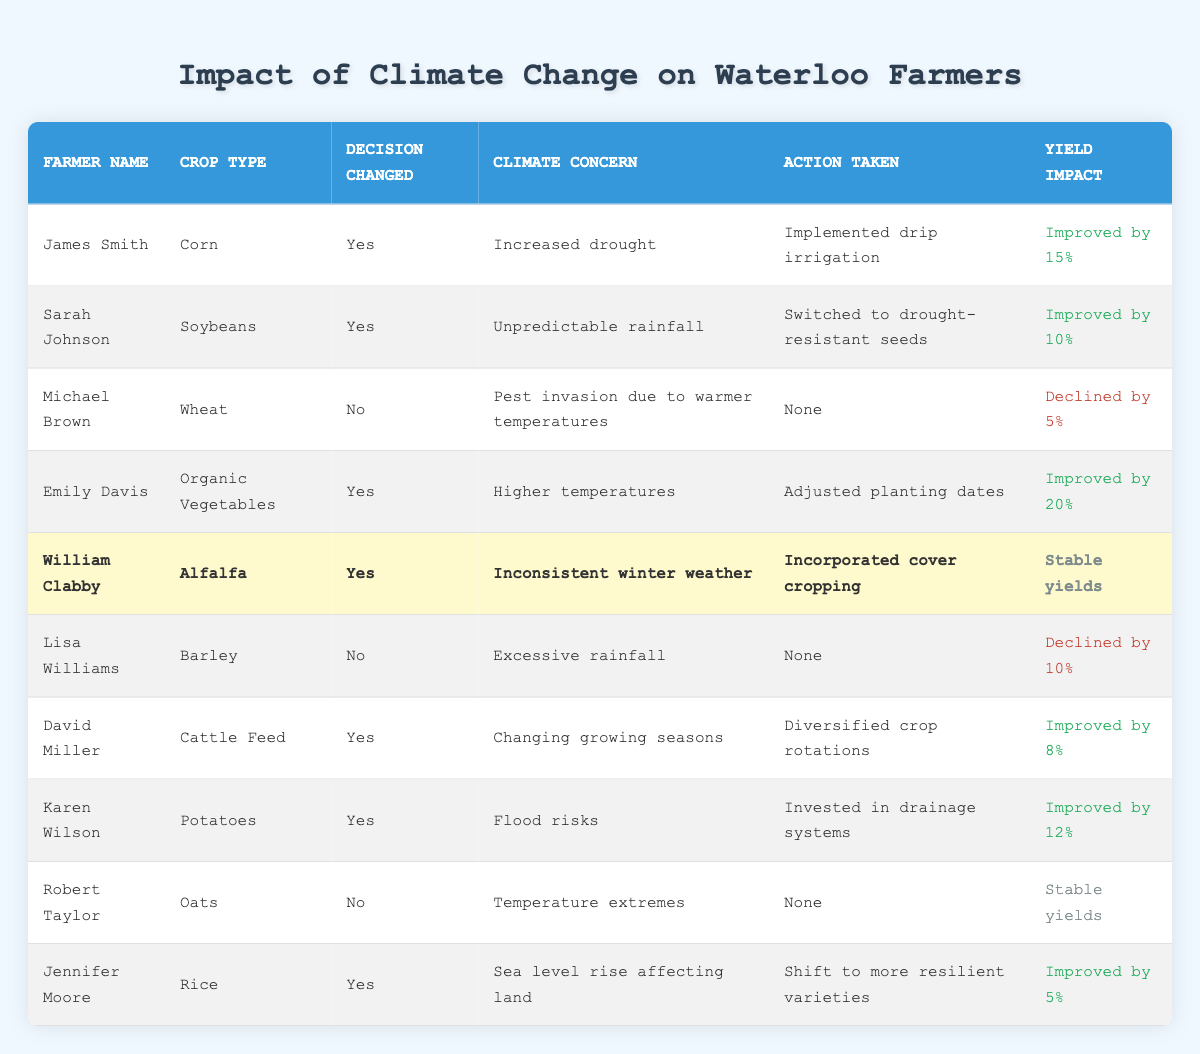What is the action taken by James Smith for the climate concern? In the table, we look for James Smith's row. In that row, the action column states "Implemented drip irrigation," which is his action corresponding to the climate concern of increased drought.
Answer: Implemented drip irrigation How many farmers changed their decisions? To find this, I count the rows where "Decision Changed" is marked as "Yes." There are six farmers with this mark: James Smith, Sarah Johnson, Emily Davis, William Clabby, David Miller, Karen Wilson, and Jennifer Moore.
Answer: 6 What is the yield impact for Michael Brown's wheat? I locate Michael Brown in the table and find the corresponding yield impact in his row. The yield impact column states "Declined by 5%," indicating the effect of his decisions.
Answer: Declined by 5% Which crop type had the highest yield improvement? I examine each yield impact in the table to find maximum improvement. Among the records, Emily Davis with "Organic Vegetables" shows the highest yield improvement of "Improved by 20%."
Answer: Organic Vegetables Did William Clabby change his farming decision? Looking at the "Decision Changed" column for William Clabby, it shows "Yes," confirming that he did change his decision based on his climate concern.
Answer: Yes What is the average percentage yield improvement among farmers who changed their decisions? I sum the yield improvements of those who changed their decisions (15% + 10% + 20% + 8% + 12% + 5% = 80%) and divide by the number of farmers who changed their decisions (6). The average yield improvement calculation is thus 80% / 6 = 13.33%.
Answer: 13.33% Is there any farmer whose action taken is to implement cover cropping? Checking the action taken column, I find that only William Clabby has "Incorporated cover cropping" as an action. Therefore, the answer to this question must be "Yes."
Answer: Yes What are the climate concerns expressed by farmers who did not change their decisions? I list the climate concerns of farmers you didn't change their decisions. Michael Brown mentions "Pest invasion due to warmer temperatures," Lisa Williams mentions "Excessive rainfall," and Robert Taylor mentions "Temperature extremes."
Answer: Pest invasion due to warmer temperatures, Excessive rainfall, Temperature extremes Which farmer experienced a decline in yield and what was the percentage? I look for yield impacts marked as negative in the table. Here, Michael Brown experienced a decline of "Declined by 5%" in yield, and Lisa Williams declined by "Declined by 10%."
Answer: Michael Brown: Declined by 5%; Lisa Williams: Declined by 10% 